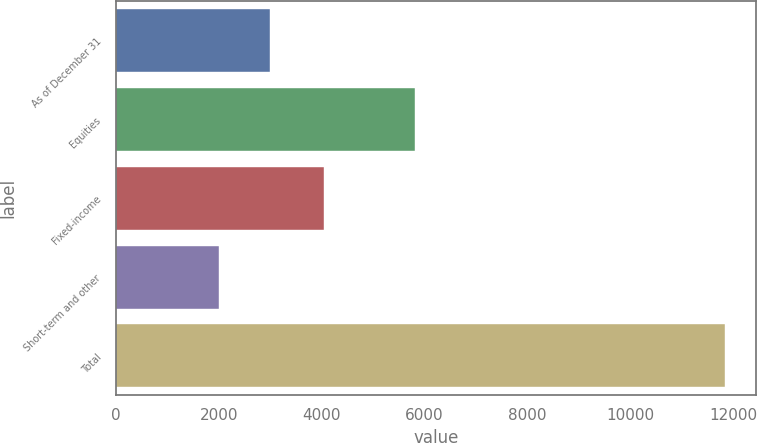<chart> <loc_0><loc_0><loc_500><loc_500><bar_chart><fcel>As of December 31<fcel>Equities<fcel>Fixed-income<fcel>Short-term and other<fcel>Total<nl><fcel>2983.6<fcel>5821<fcel>4035<fcel>1998<fcel>11854<nl></chart> 